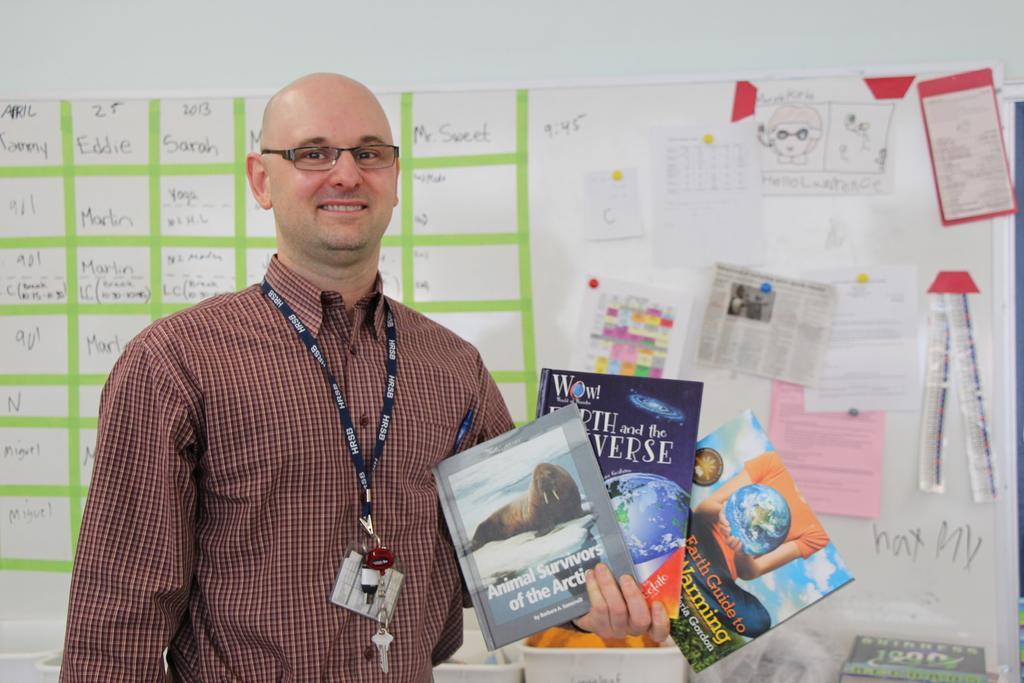In one or two sentences, can you explain what this image depicts? Bottom left side of the image a man is standing and holding some books. Behind him there is a wall, on the wall there is a board and there are some posters. 